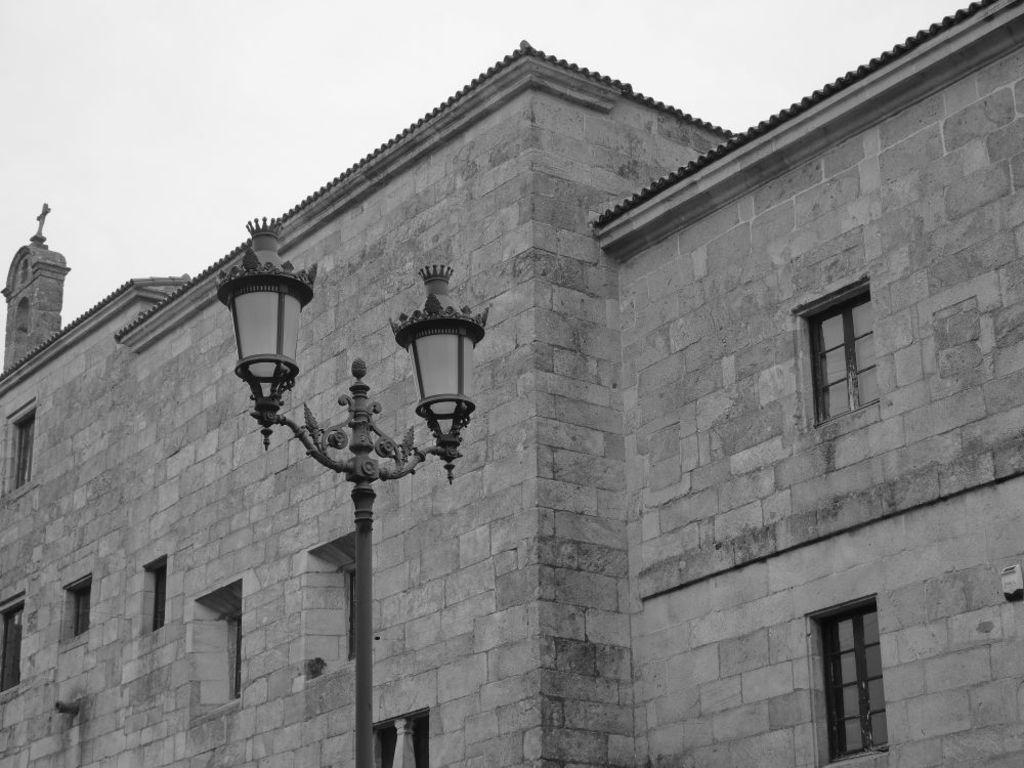What is the color scheme of the image? The image is black and white. What is located in front of the building in the image? There is a pole with lights in the image. What can be seen behind the pole in the image? There is a building behind the pole. What is visible at the top of the image? The sky is visible in the image. What type of fruit is hanging from the pole in the image? There is no fruit present in the image; it features a pole with lights and a building in the background. Can you see a heart-shaped object in the image? There is no heart-shaped object present in the image. 